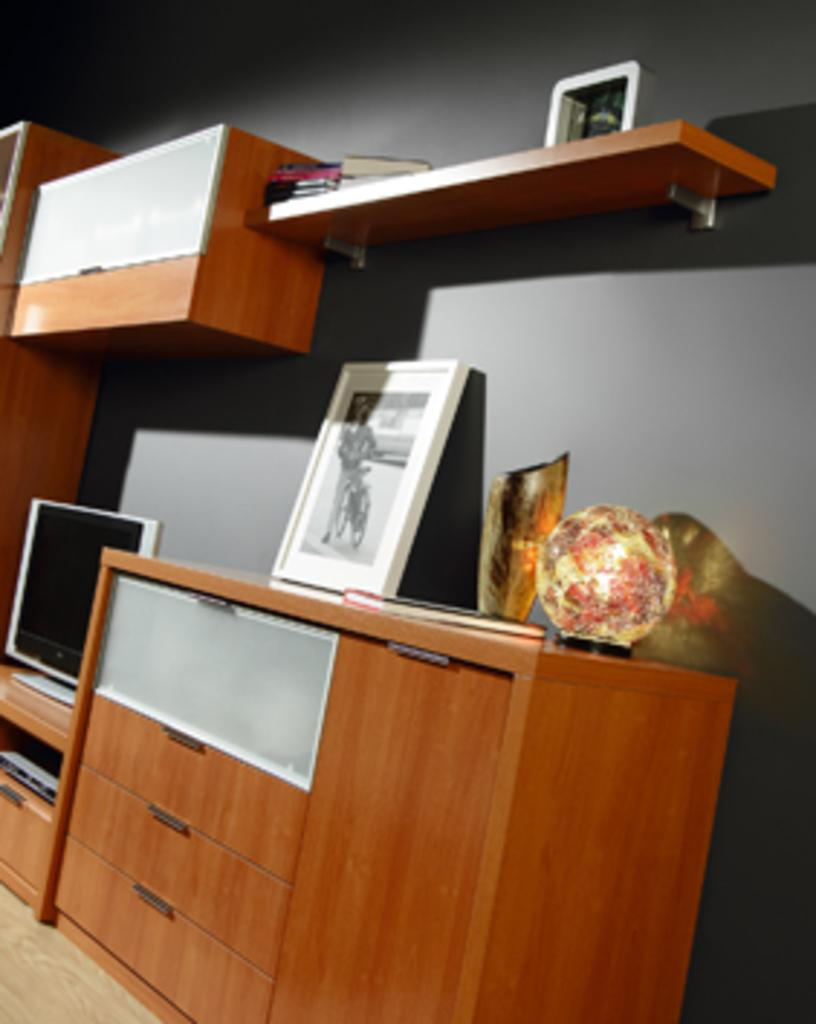What type of furniture is present in the image? There is a cupboard in the image. What is placed on the cupboard? A photo frame, books, and other things are placed on the cupboard. Can you describe one of the items placed on the cupboard? There is a monitor on the cupboard. What type of cattle can be seen grazing in the image? There are no cattle present in the image; it features a cupboard with various items on it. 